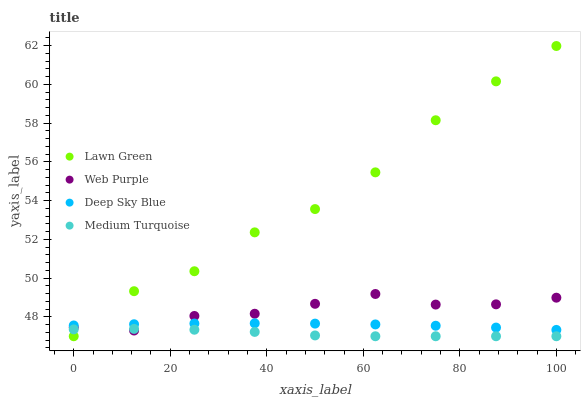Does Medium Turquoise have the minimum area under the curve?
Answer yes or no. Yes. Does Lawn Green have the maximum area under the curve?
Answer yes or no. Yes. Does Web Purple have the minimum area under the curve?
Answer yes or no. No. Does Web Purple have the maximum area under the curve?
Answer yes or no. No. Is Deep Sky Blue the smoothest?
Answer yes or no. Yes. Is Lawn Green the roughest?
Answer yes or no. Yes. Is Web Purple the smoothest?
Answer yes or no. No. Is Web Purple the roughest?
Answer yes or no. No. Does Lawn Green have the lowest value?
Answer yes or no. Yes. Does Web Purple have the lowest value?
Answer yes or no. No. Does Lawn Green have the highest value?
Answer yes or no. Yes. Does Web Purple have the highest value?
Answer yes or no. No. Is Medium Turquoise less than Deep Sky Blue?
Answer yes or no. Yes. Is Deep Sky Blue greater than Medium Turquoise?
Answer yes or no. Yes. Does Deep Sky Blue intersect Lawn Green?
Answer yes or no. Yes. Is Deep Sky Blue less than Lawn Green?
Answer yes or no. No. Is Deep Sky Blue greater than Lawn Green?
Answer yes or no. No. Does Medium Turquoise intersect Deep Sky Blue?
Answer yes or no. No. 